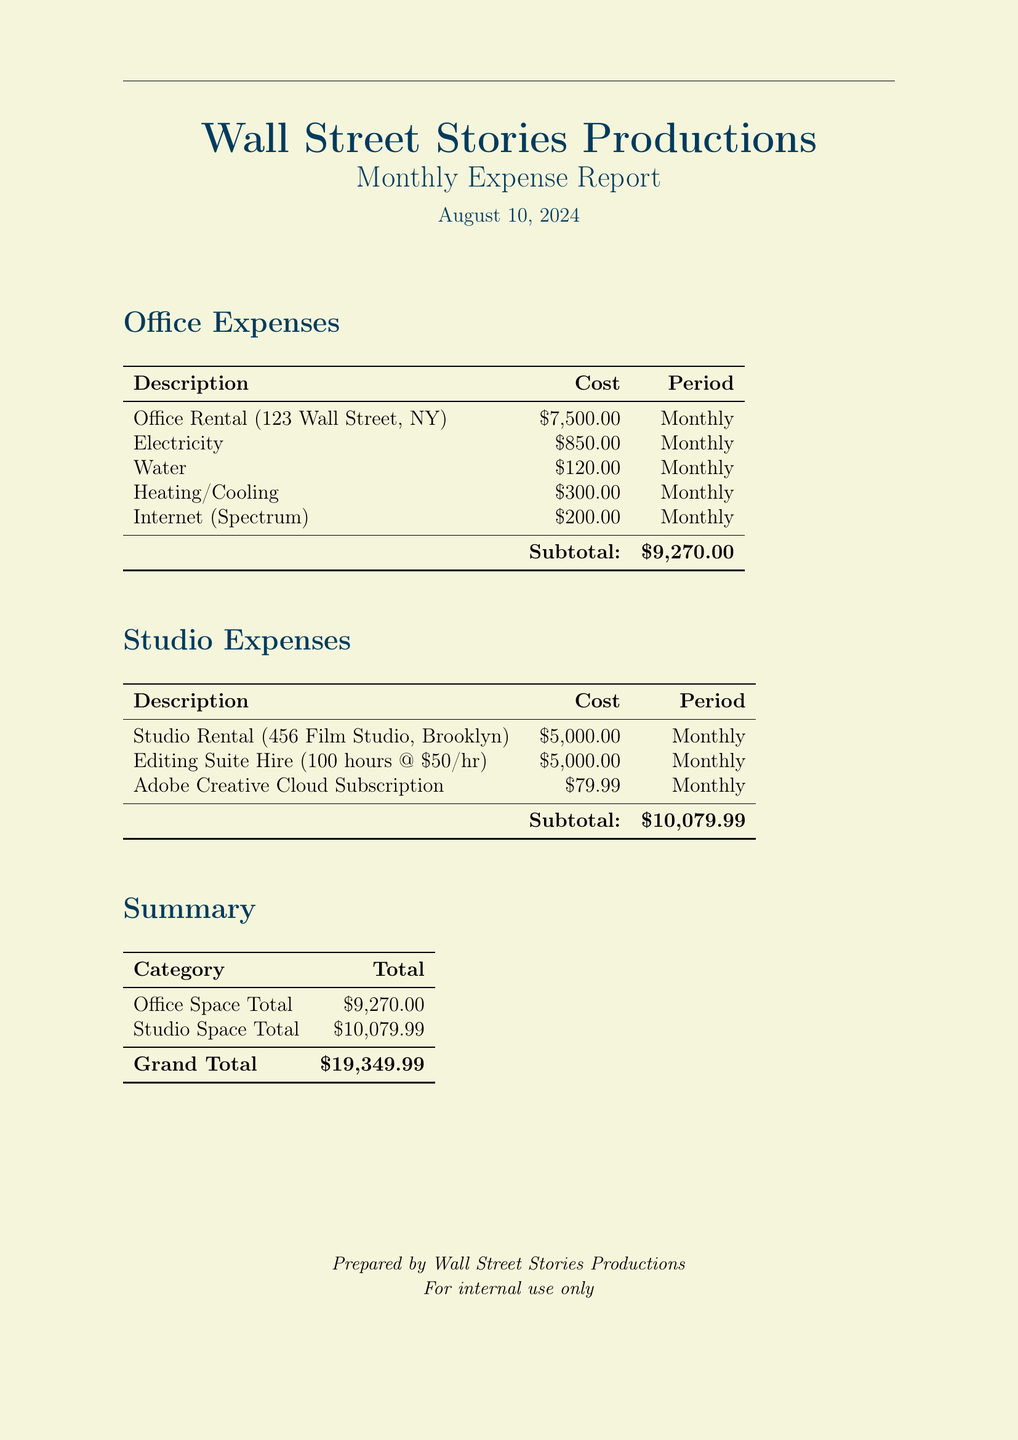What is the total cost of office rental? The total cost of office rental is listed in the document under the office expenses section, which is $7,500.00.
Answer: $7,500.00 What is the cost of electricity? The cost of electricity is detailed in the office expenses section as $850.00 per month.
Answer: $850.00 How much was spent on studio rental? The cost for studio rental is provided in the studio expenses section, which amounts to $5,000.00.
Answer: $5,000.00 What is the grand total of all expenses? The grand total is calculated as the sum of both office and studio expenses, equating to $19,349.99.
Answer: $19,349.99 How much was charged for the Adobe Creative Cloud Subscription? The document indicates that the Adobe Creative Cloud Subscription costs $79.99 per month.
Answer: $79.99 What period do the expenses cover? The document specifies that all listed costs are on a monthly basis, as indicated in each section.
Answer: Monthly How much was spent on editing suite hire? The cost for editing suite hire is stated as $5,000.00 for 100 hours at $50 per hour in the studio expenses.
Answer: $5,000.00 What is the total cost for utilities (excluding internet)? The costs for utilities are outlined in the office expenses section and sum up to $1,270.00 ($850 + $120 + $300).
Answer: $1,270.00 What was the total spent on office and studio expenses? The total spent can be derived from the separate totals of $9,270.00 for office expenses and $10,079.99 for studio expenses.
Answer: $19,349.99 